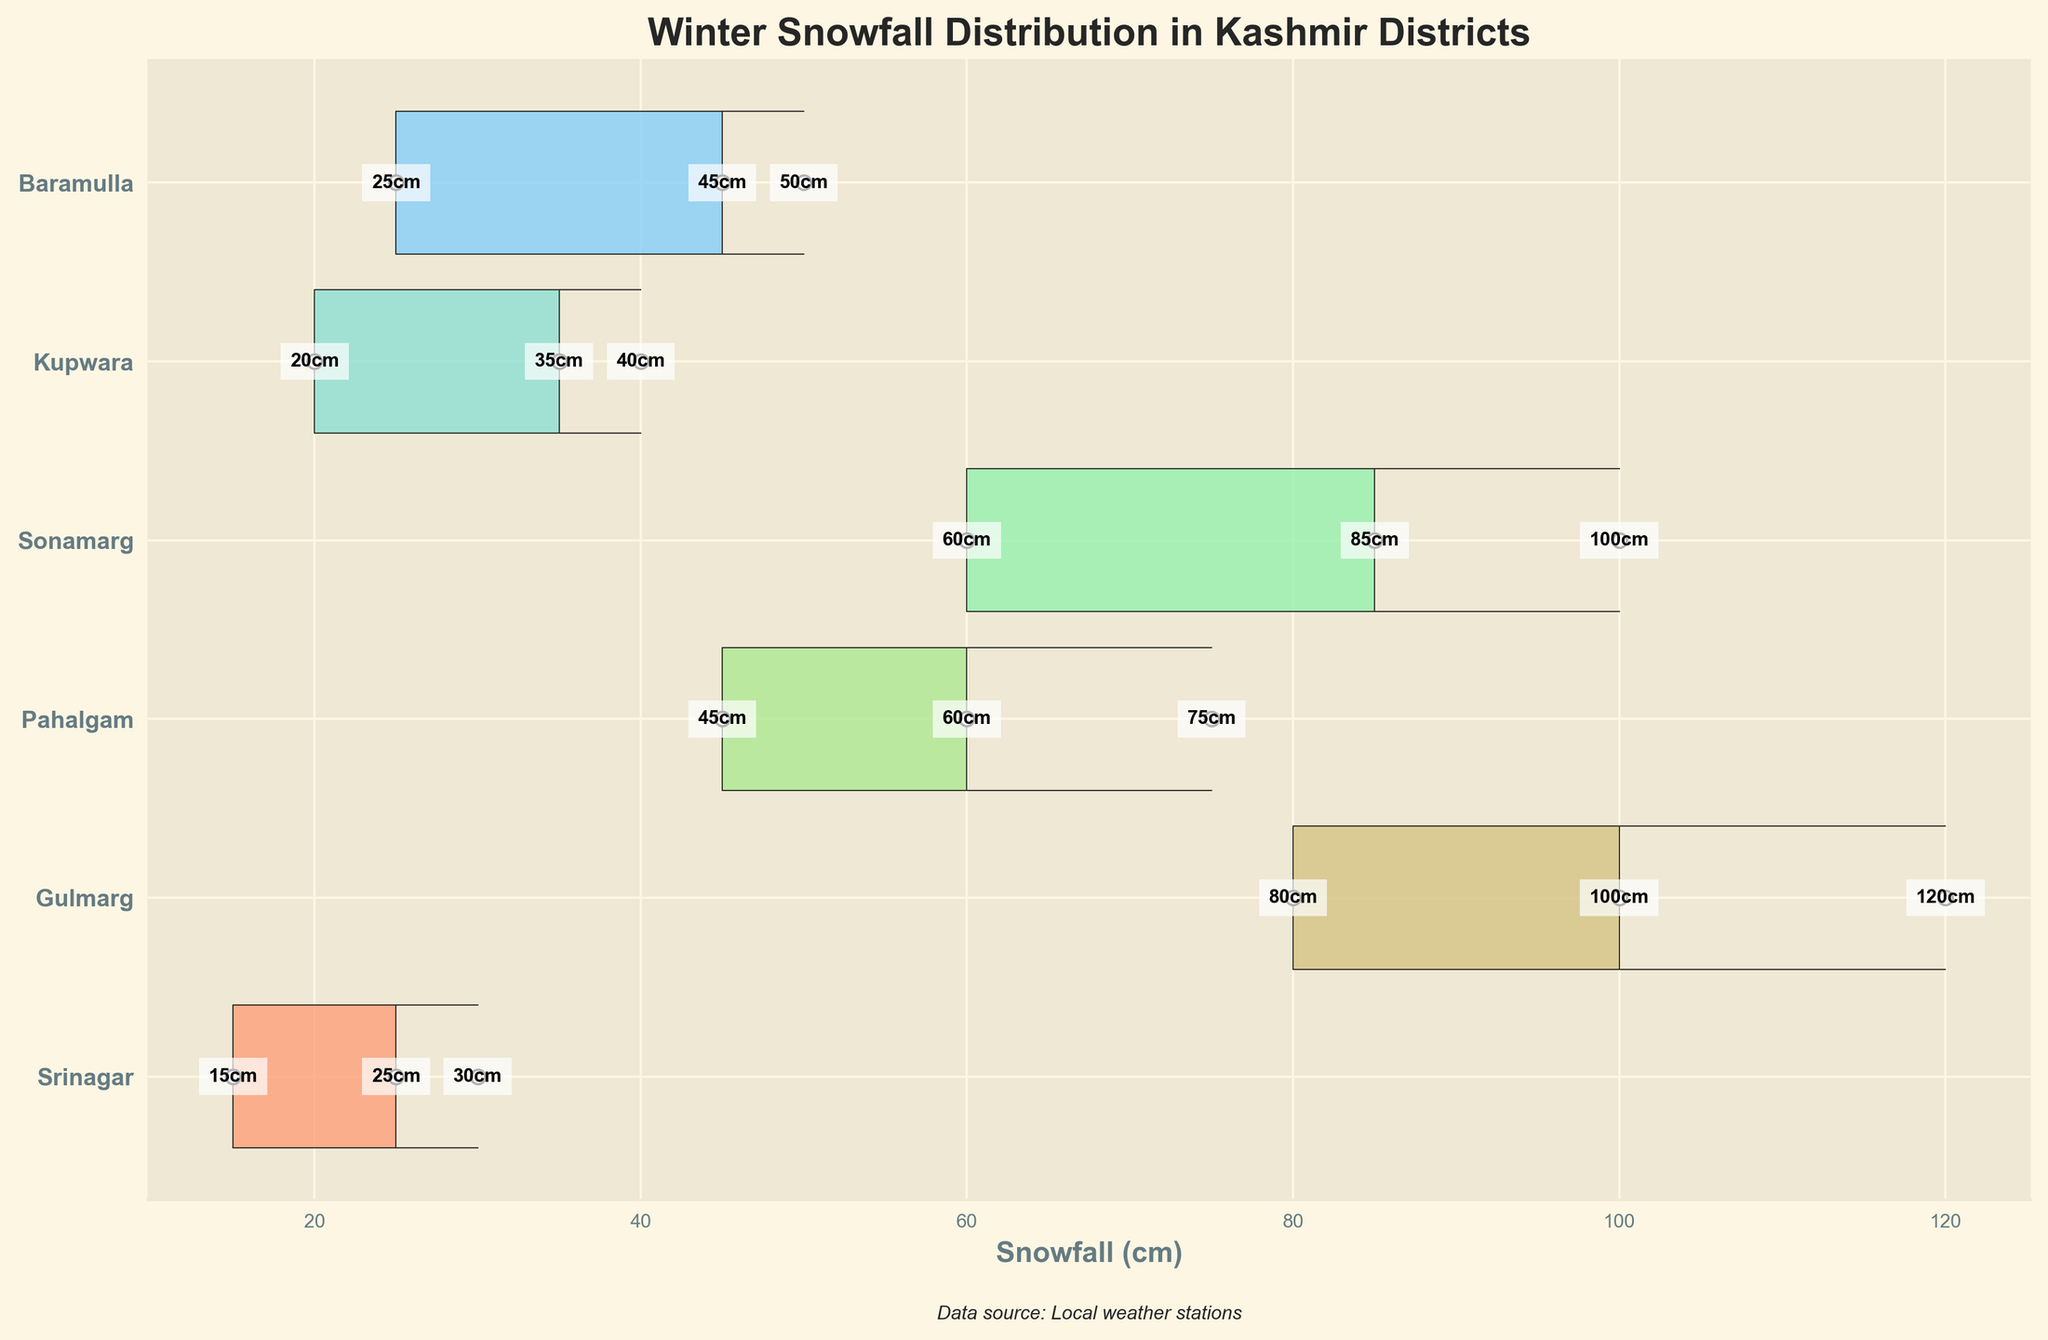What is the title of the plot? The title is written at the top of the plot.
Answer: Winter Snowfall Distribution in Kashmir Districts Which district has the highest snowfall in December? Look at the snowfall amounts along the x-axis and identify the highest value for December.
Answer: Gulmarg How much snowfall did Srinagar receive in January? Check the snowfall amount labeled next to the point for Srinagar in January.
Answer: 30 cm Which district recorded the lowest snowfall in February? Examine the snowfall values for February for each district and find the smallest one.
Answer: Srinagar What is the difference in snowfall between Gulmarg and Pahalgam in January? Subtract the snowfall amount of Pahalgam in January from that of Gulmarg in January.
Answer: 45 cm How does the snowfall in Sonamarg in December compare to Srinagar in December? Compare the snowfall values for Sonamarg and Srinagar in December.
Answer: Sonamarg has more snowfall Which month generally has the highest snowfall across all districts? Observe the snowfall amounts across all districts for each month and identify the month with generally higher values.
Answer: January What is the average snowfall in Baramulla across the three months? Add the snowfall values for Baramulla for December, January, and February, then divide by three.
Answer: 40 cm How many districts had snowfall amounts of at least 100 cm in any month? Count the number of districts that have snowfall amounts recorded at 100 cm or more for any of the three months.
Answer: 2 districts What is the total snowfall recorded in Kupwara over the three winter months? Sum up the snowfall values for Kupwara in December, January, and February.
Answer: 95 cm 